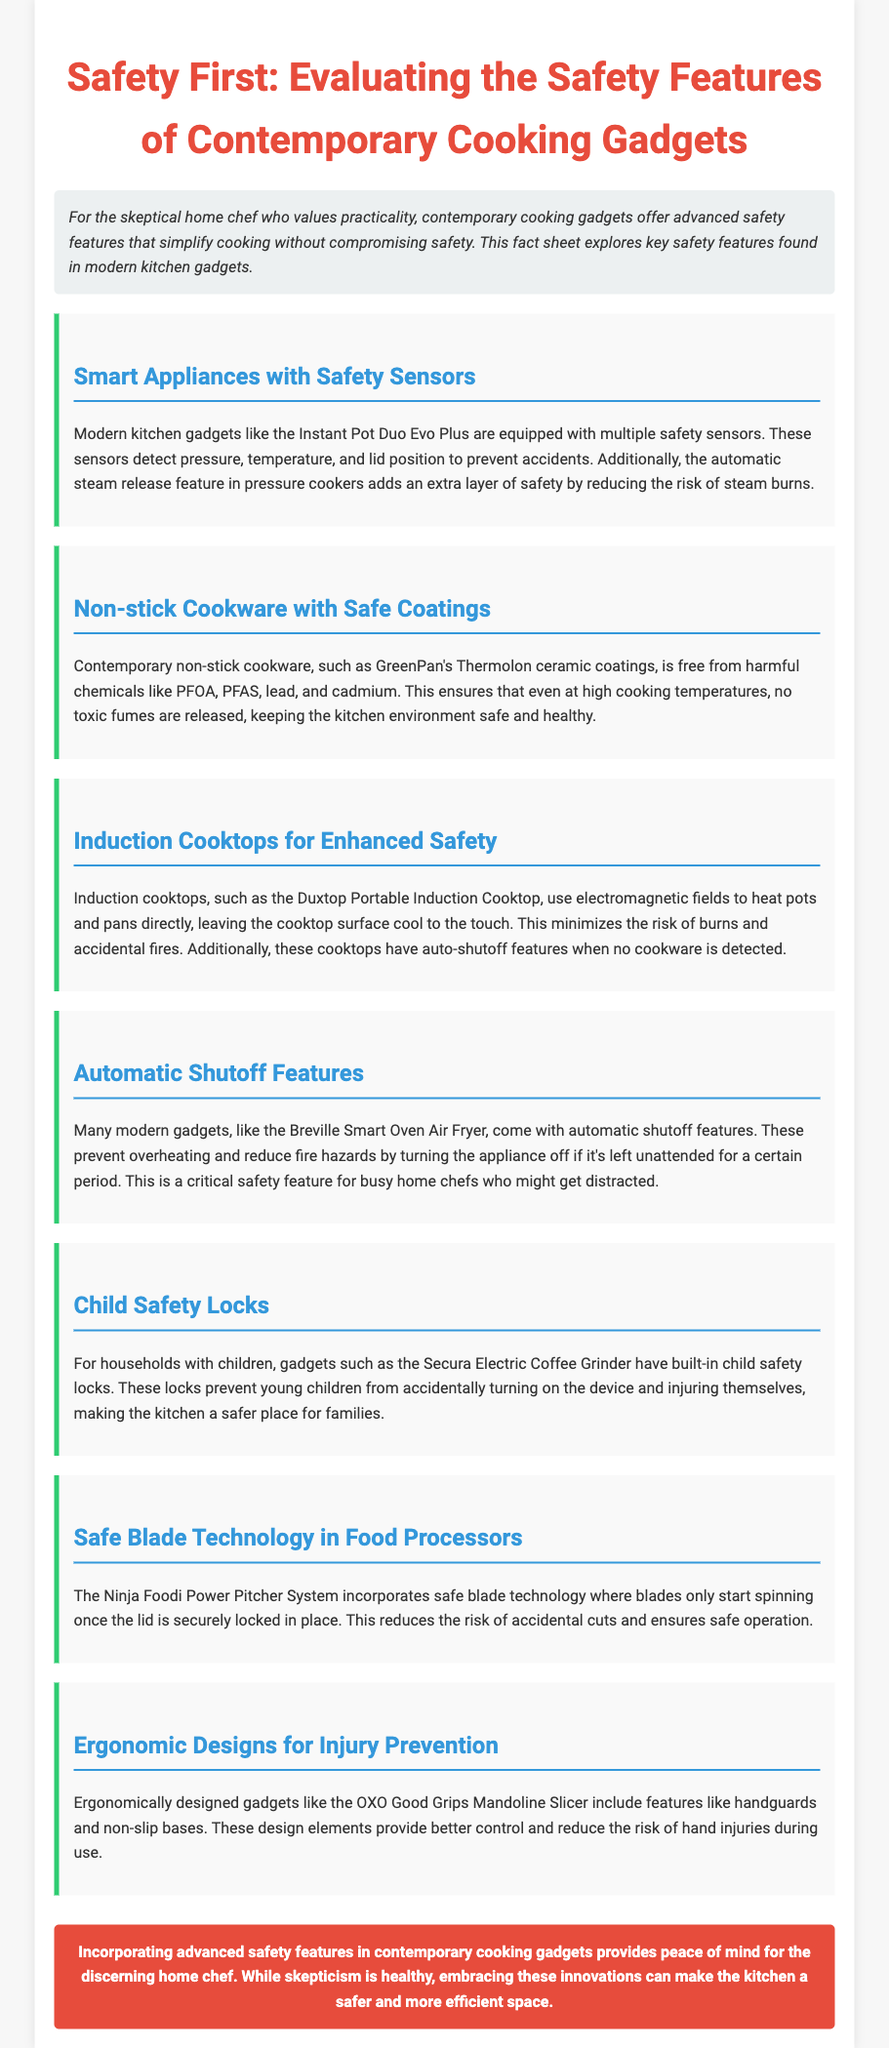what is the main focus of the fact sheet? The main focus of the fact sheet is to evaluate the safety features of contemporary cooking gadgets for home chefs.
Answer: safety features who manufactures the Instant Pot Duo Evo Plus? The document mentions the Instant Pot Duo Evo Plus but does not provide the manufacturer's name.
Answer: Not specified what type of cookware is mentioned as being safe? The fact sheet discusses non-stick cookware specifically and mentions a brand called GreenPan.
Answer: non-stick cookware which kitchen gadget has a child safety lock? The Secura Electric Coffee Grinder is specifically mentioned as having a child safety lock feature.
Answer: Secura Electric Coffee Grinder what technology minimizes the risk of burns on cooktops? Induction cooktops utilize electromagnetic fields, which leave the surface cool to the touch and minimize burn risks.
Answer: Induction cooktops how does the Ninja Foodi Power Pitcher System ensure blade safety? The blade technology only allows the blades to spin when the lid is securely locked in place, enhancing operational safety.
Answer: safe blade technology what safety feature is emphasized for busy home chefs? Automatic shutoff features are emphasized to prevent overheating and reduce fire hazards for busy home chefs.
Answer: Automatic shutoff features name an ergonomic design feature mentioned in the document. The OXO Good Grips Mandoline Slicer has handguards and non-slip bases as ergonomic design features.
Answer: handguards and non-slip bases 